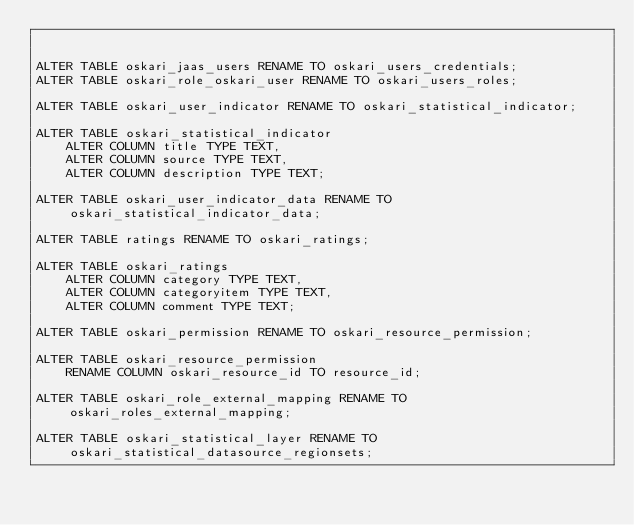Convert code to text. <code><loc_0><loc_0><loc_500><loc_500><_SQL_>

ALTER TABLE oskari_jaas_users RENAME TO oskari_users_credentials;
ALTER TABLE oskari_role_oskari_user RENAME TO oskari_users_roles;

ALTER TABLE oskari_user_indicator RENAME TO oskari_statistical_indicator;

ALTER TABLE oskari_statistical_indicator
    ALTER COLUMN title TYPE TEXT,
    ALTER COLUMN source TYPE TEXT,
    ALTER COLUMN description TYPE TEXT;

ALTER TABLE oskari_user_indicator_data RENAME TO oskari_statistical_indicator_data;

ALTER TABLE ratings RENAME TO oskari_ratings;

ALTER TABLE oskari_ratings
    ALTER COLUMN category TYPE TEXT,
    ALTER COLUMN categoryitem TYPE TEXT,
    ALTER COLUMN comment TYPE TEXT;

ALTER TABLE oskari_permission RENAME TO oskari_resource_permission;

ALTER TABLE oskari_resource_permission
    RENAME COLUMN oskari_resource_id TO resource_id;

ALTER TABLE oskari_role_external_mapping RENAME TO oskari_roles_external_mapping;

ALTER TABLE oskari_statistical_layer RENAME TO oskari_statistical_datasource_regionsets;
</code> 